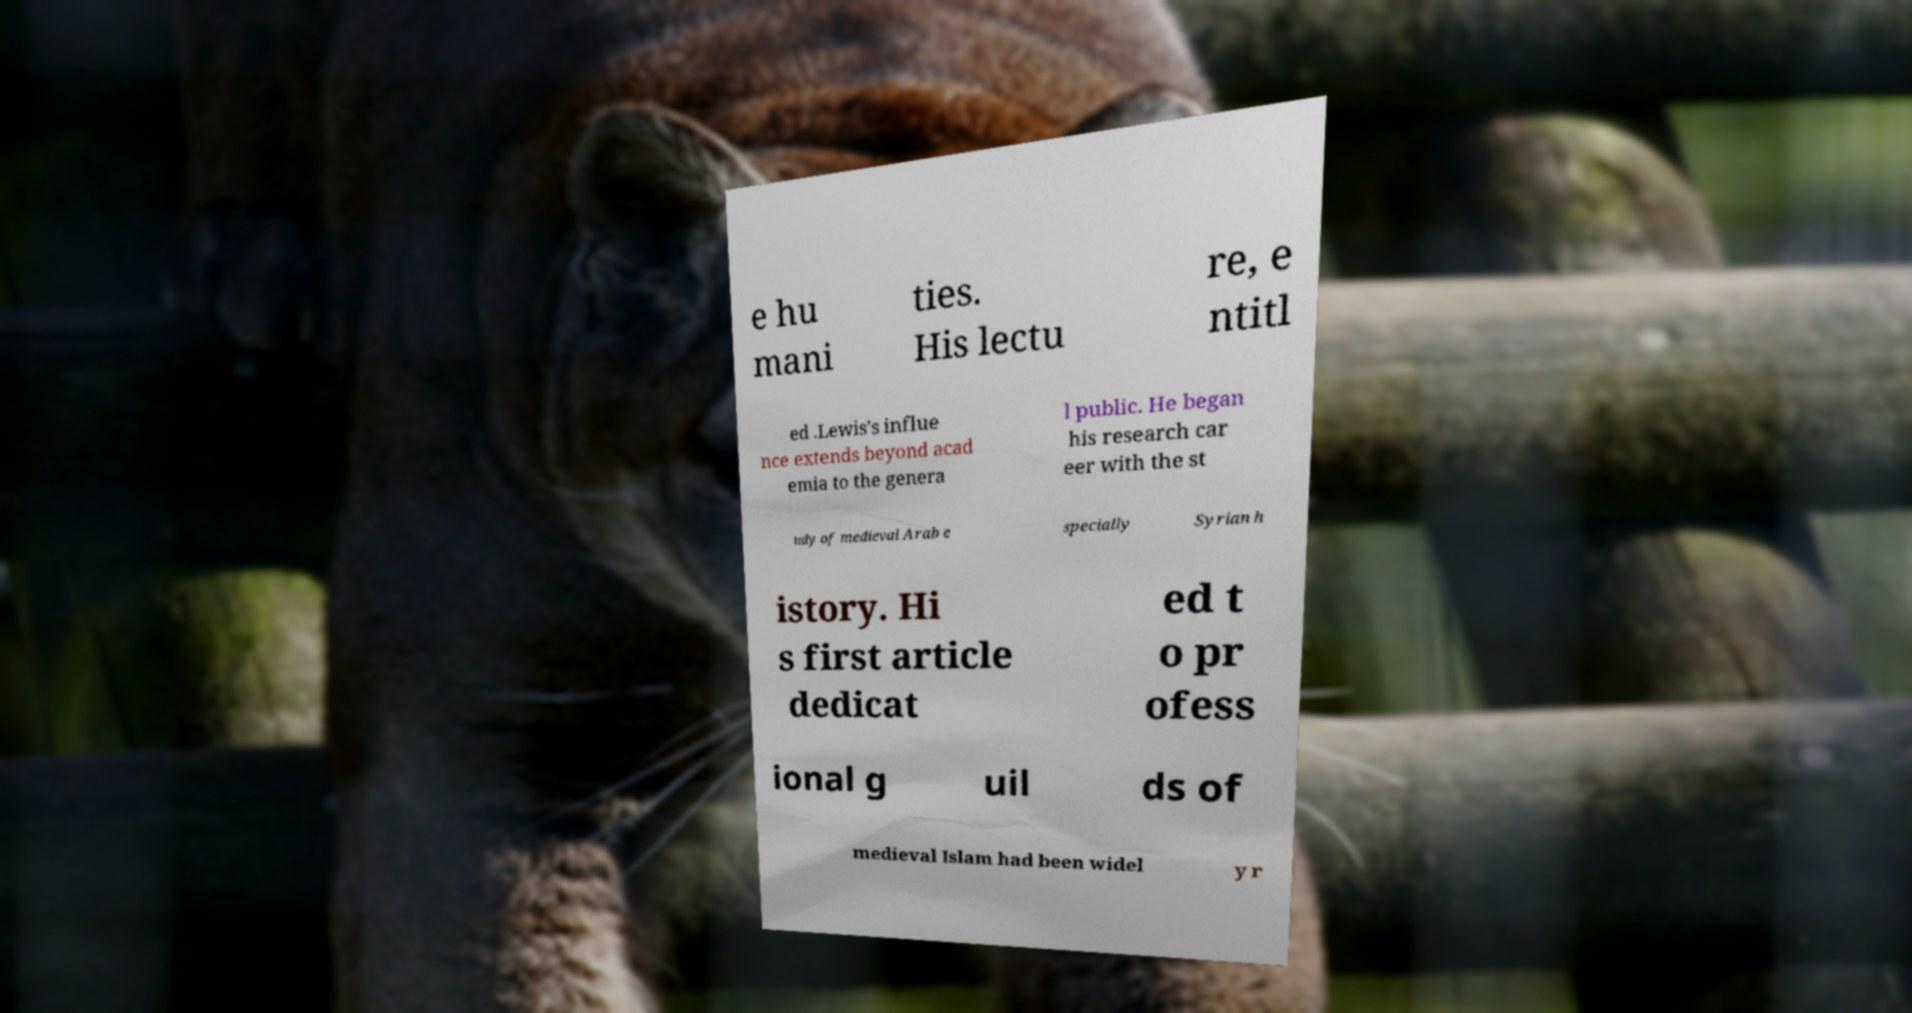Can you read and provide the text displayed in the image?This photo seems to have some interesting text. Can you extract and type it out for me? e hu mani ties. His lectu re, e ntitl ed .Lewis's influe nce extends beyond acad emia to the genera l public. He began his research car eer with the st udy of medieval Arab e specially Syrian h istory. Hi s first article dedicat ed t o pr ofess ional g uil ds of medieval Islam had been widel y r 